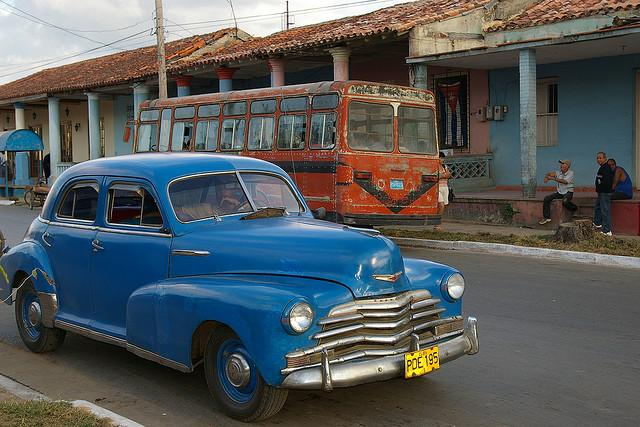Why are the vehicles so old?

Choices:
A) people poor
B) vintage collectors
C) cuban embargo
D) old picture cuban embargo 